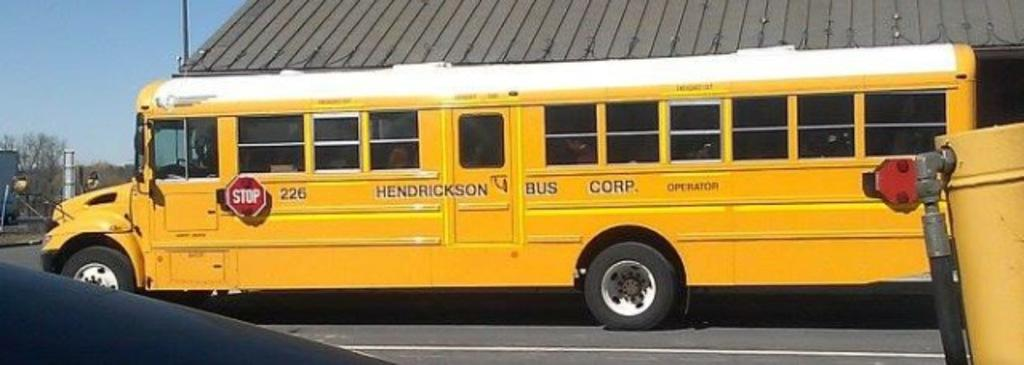<image>
Offer a succinct explanation of the picture presented. a hendrickson bus corp bus parked  next to a building 